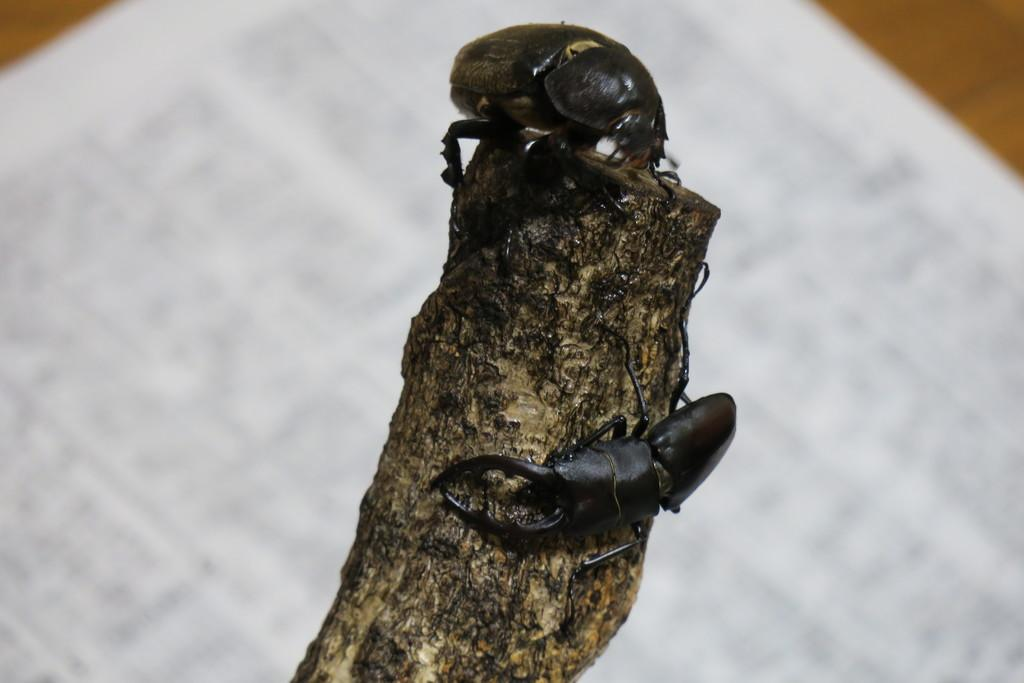What is the main object in the image? There is a wooden log in the image. What is present on the wooden log? There are two insects on the wooden log. What is the color of the insects? The insects are black in color. What can be seen in the background of the image? There are brown and white colored objects in the background of the image. What type of eggnog is being served at the birthday party in the image? There is no eggnog or birthday party present in the image. What type of veil is being worn by the person in the image? There is no person or veil present in the image. 